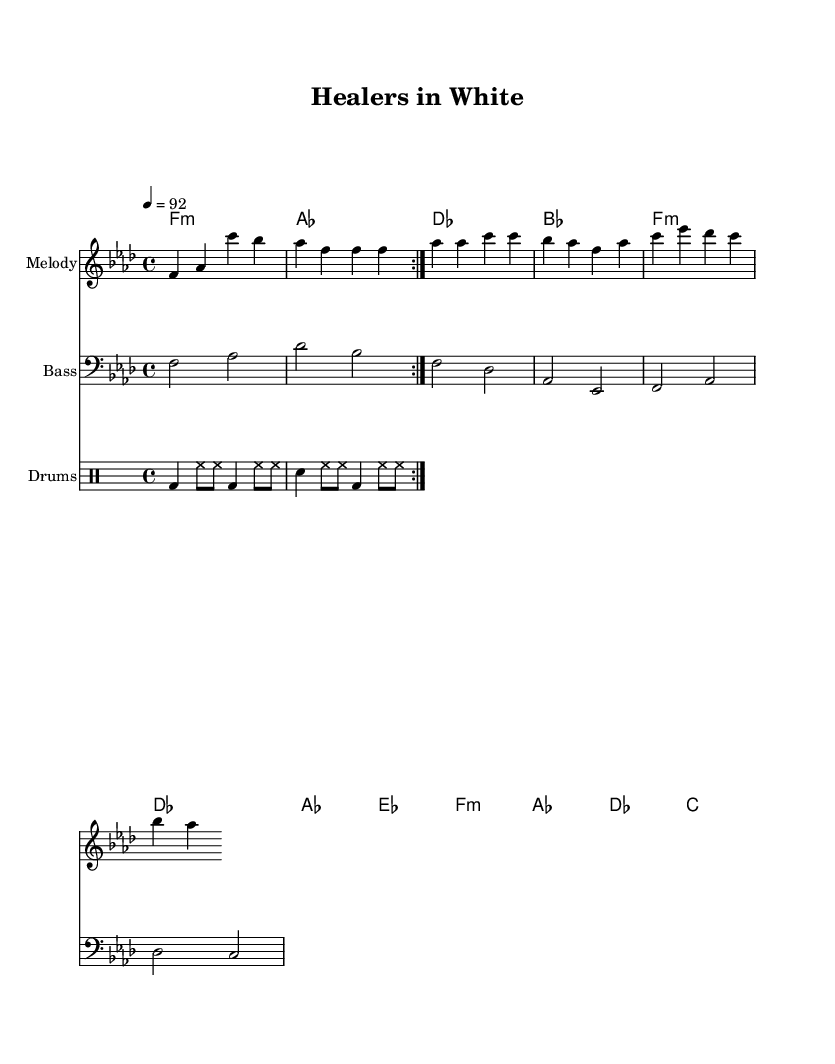What is the key signature of this piece? The key signature is indicated by the number of flats or sharps at the beginning of the staff, and in this sheet music, there are four flats, which corresponds to the key of F minor.
Answer: F minor What is the time signature of this music? The time signature is shown as a fraction at the beginning of the staff. Here, we see a 4 over 4, meaning there are four beats in a measure, and the quarter note gets one beat.
Answer: 4/4 What is the tempo marking for this piece? The tempo marking is noted as a numerical value followed by an equal sign. In this case, it says 4 equals 92, indicating the speed at which the music should be played.
Answer: 92 How many measures are in the chorus section? To determine the number of measures in the chorus, we analyze the melody line. The chorus segment has four lines of music, and each line consists of one measure, resulting in four measures in total.
Answer: 4 What are the primary instruments indicated in the score? The score section labels reveal the instruments used, including a melody line, a bass section, and a drum pattern. Thus, the primary instruments are voice (melody), bass, and drums.
Answer: Melody, Bass, Drums How many times does the drum pattern repeat in the score? Within the drum pattern section marked with "repeat volta 2," it indicates that the specified drum measures are to be played two times, confirming the repetition count.
Answer: 2 